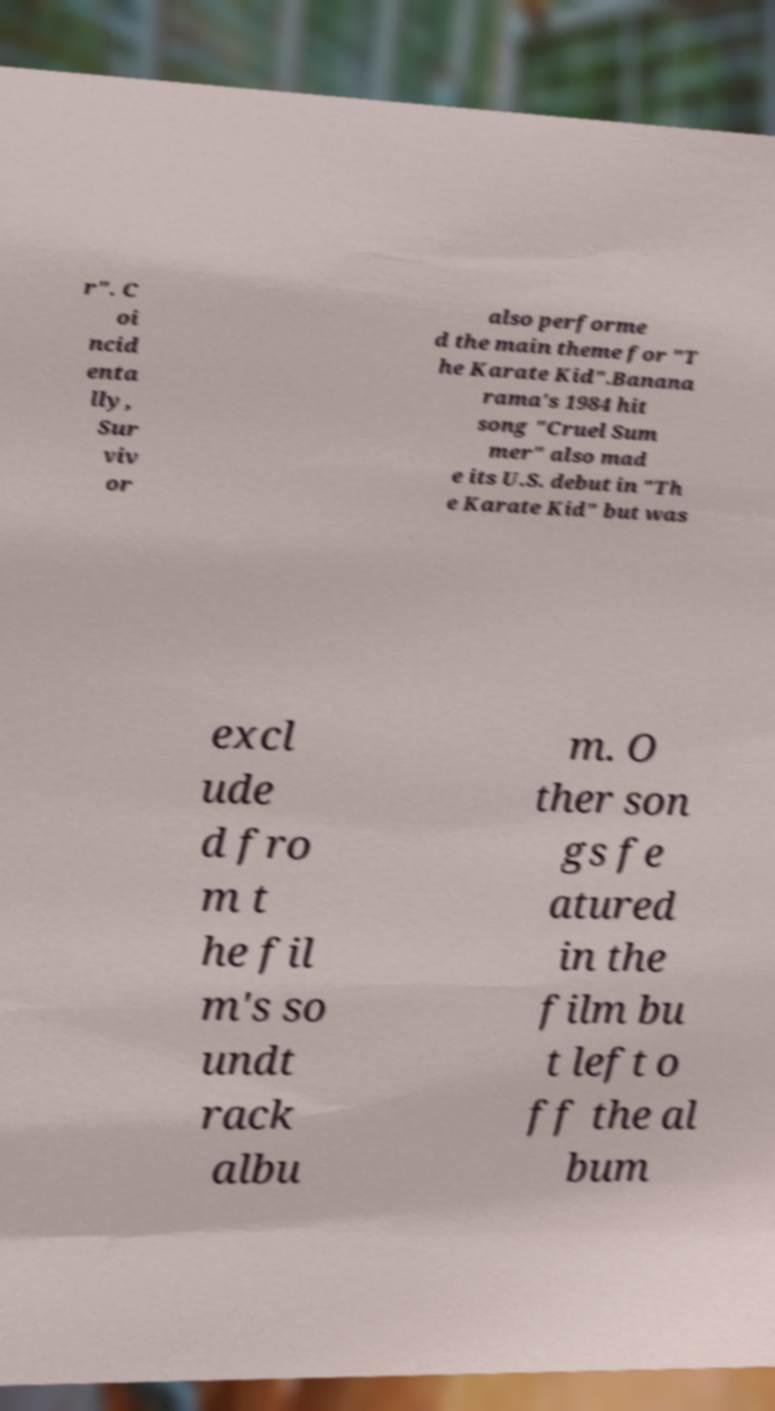Can you read and provide the text displayed in the image?This photo seems to have some interesting text. Can you extract and type it out for me? r". C oi ncid enta lly, Sur viv or also performe d the main theme for "T he Karate Kid".Banana rama's 1984 hit song "Cruel Sum mer" also mad e its U.S. debut in "Th e Karate Kid" but was excl ude d fro m t he fil m's so undt rack albu m. O ther son gs fe atured in the film bu t left o ff the al bum 